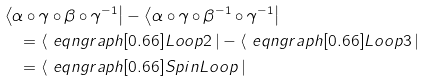Convert formula to latex. <formula><loc_0><loc_0><loc_500><loc_500>& \left \langle \alpha \circ \gamma \circ \beta \circ \gamma ^ { - 1 } \right | - \left \langle \alpha \circ \gamma \circ \beta ^ { - 1 } \circ \gamma ^ { - 1 } \right | \\ & \quad = \left \langle \ e q n g r a p h [ 0 . 6 6 ] { L o o p 2 } \, \right | - \left \langle \ e q n g r a p h [ 0 . 6 6 ] { L o o p 3 } \, \right | \\ & \quad = \left \langle \ e q n g r a p h [ 0 . 6 6 ] { S p i n L o o p } \, \right |</formula> 